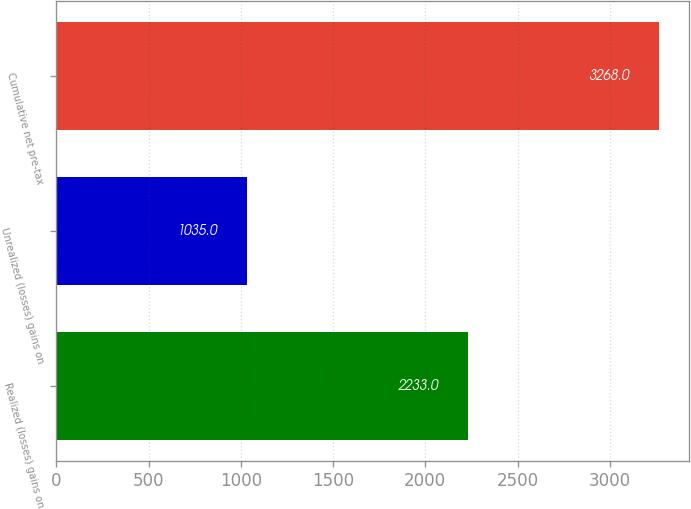Convert chart. <chart><loc_0><loc_0><loc_500><loc_500><bar_chart><fcel>Realized (losses) gains on<fcel>Unrealized (losses) gains on<fcel>Cumulative net pre-tax<nl><fcel>2233<fcel>1035<fcel>3268<nl></chart> 